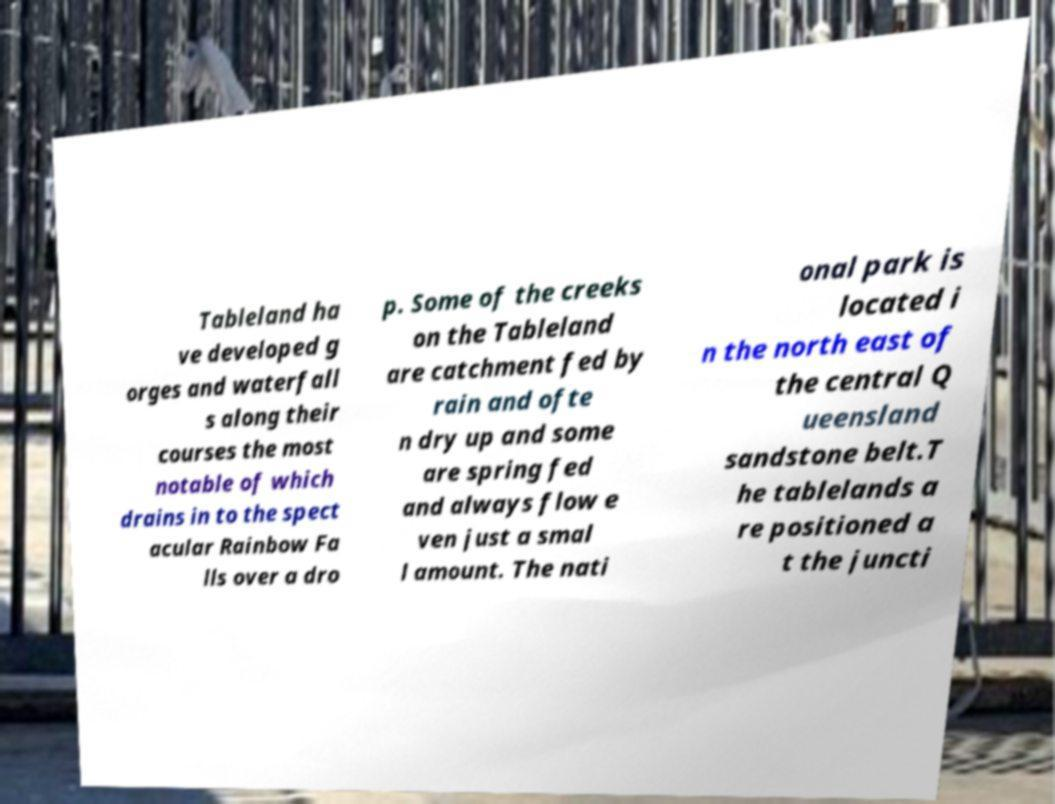Could you assist in decoding the text presented in this image and type it out clearly? Tableland ha ve developed g orges and waterfall s along their courses the most notable of which drains in to the spect acular Rainbow Fa lls over a dro p. Some of the creeks on the Tableland are catchment fed by rain and ofte n dry up and some are spring fed and always flow e ven just a smal l amount. The nati onal park is located i n the north east of the central Q ueensland sandstone belt.T he tablelands a re positioned a t the juncti 